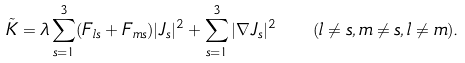<formula> <loc_0><loc_0><loc_500><loc_500>\tilde { K } = \lambda \sum _ { s = 1 } ^ { 3 } ( F _ { l s } + F _ { m s } ) | J _ { s } | ^ { 2 } + \sum _ { s = 1 } ^ { 3 } | \nabla J _ { s } | ^ { 2 } \quad ( l \neq s , m \neq s , l \neq m ) .</formula> 